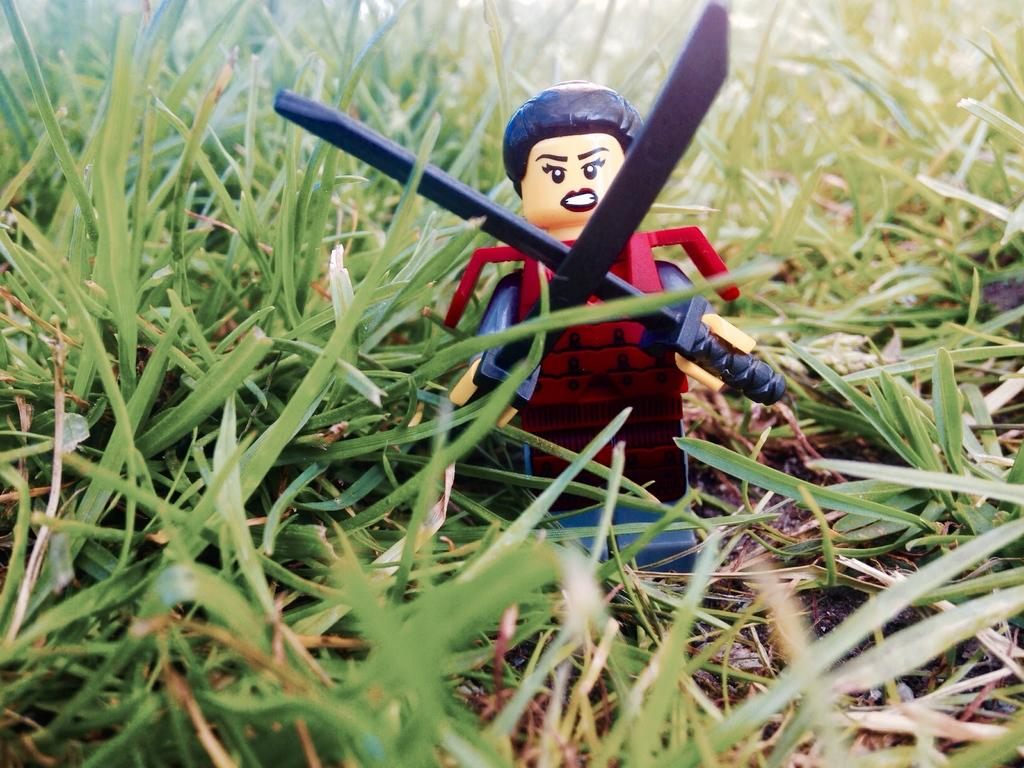What is the main object in the center of the image? There is a toy in the center of the image. What type of natural environment can be seen in the image? There is grass visible in the image. What is the rate of the church bells ringing in the image? There is no church or bells present in the image, so it is not possible to determine a rate. 